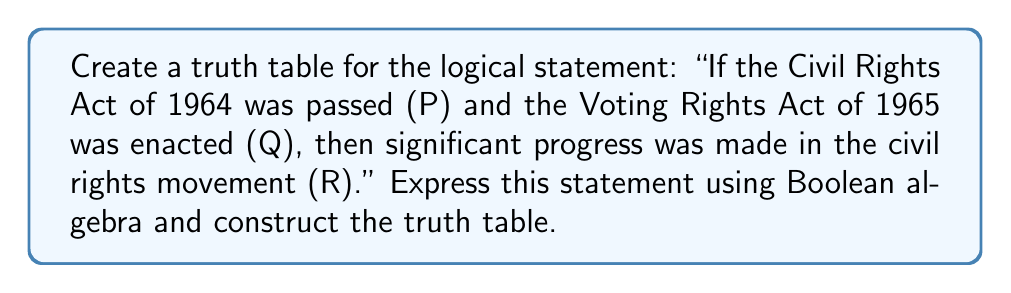Could you help me with this problem? Let's approach this step-by-step:

1) First, we need to express the statement in Boolean algebra. The statement can be written as:

   $$(P \land Q) \rightarrow R$$

   Where $\land$ represents AND, and $\rightarrow$ represents IMPLIES.

2) To create a truth table, we need to consider all possible combinations of truth values for P, Q, and R. There are 8 possible combinations (2^3).

3) We'll evaluate the expression $(P \land Q)$ first, then the entire statement $(P \land Q) \rightarrow R$.

4) Remember, for $A \rightarrow B$, the result is false only when A is true and B is false. Otherwise, it's true.

5) Here's the truth table:

   $$\begin{array}{|c|c|c|c|c|c|}
   \hline
   P & Q & R & P \land Q & (P \land Q) \rightarrow R \\
   \hline
   T & T & T & T & T \\
   T & T & F & T & F \\
   T & F & T & F & T \\
   T & F & F & F & T \\
   F & T & T & F & T \\
   F & T & F & F & T \\
   F & F & T & F & T \\
   F & F & F & F & T \\
   \hline
   \end{array}$$

6) The truth table shows that the statement is false only when both the Civil Rights Act and the Voting Rights Act were passed (P and Q are true), but significant progress was not made (R is false).

This logical analysis reflects the historical significance of these acts in the civil rights movement, which would be familiar to a History major from Tougaloo College, an institution known for its involvement in the civil rights movement.
Answer: $$\begin{array}{|c|c|c|c|c|}
\hline
P & Q & R & P \land Q & (P \land Q) \rightarrow R \\
\hline
T & T & T & T & T \\
T & T & F & T & F \\
T & F & T & F & T \\
T & F & F & F & T \\
F & T & T & F & T \\
F & T & F & F & T \\
F & F & T & F & T \\
F & F & F & F & T \\
\hline
\end{array}$$ 